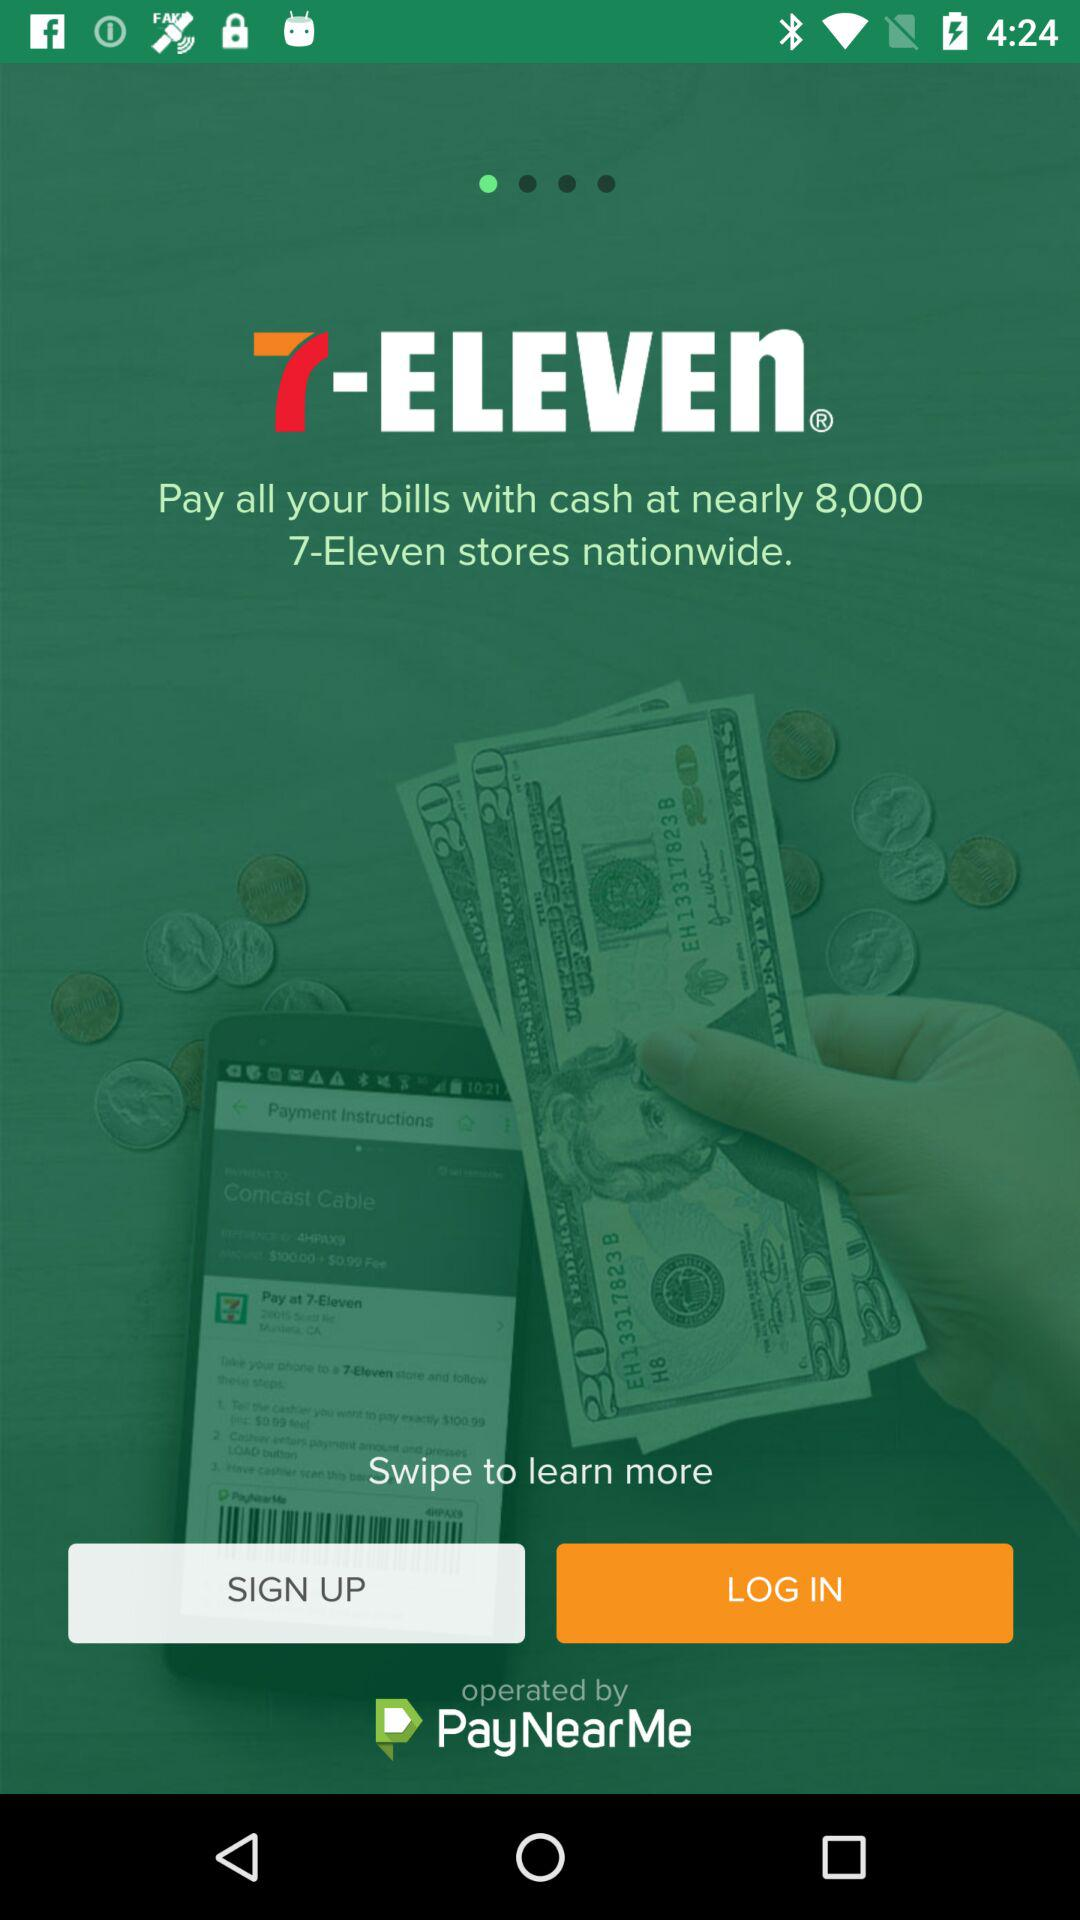By which company is the application operated? The application is operated by "PayNearMe". 